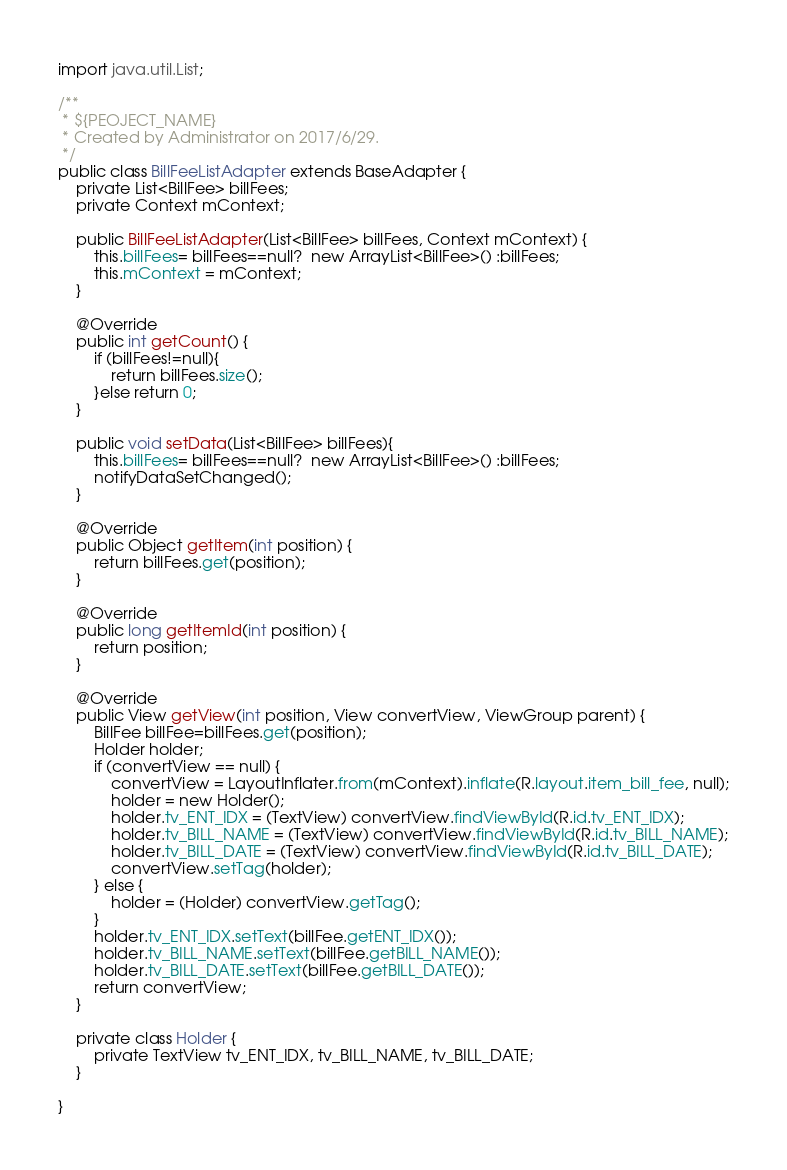<code> <loc_0><loc_0><loc_500><loc_500><_Java_>import java.util.List;

/**
 * ${PEOJECT_NAME}
 * Created by Administrator on 2017/6/29.
 */
public class BillFeeListAdapter extends BaseAdapter {
    private List<BillFee> billFees;
    private Context mContext;

    public BillFeeListAdapter(List<BillFee> billFees, Context mContext) {
        this.billFees= billFees==null?  new ArrayList<BillFee>() :billFees;
        this.mContext = mContext;
    }

    @Override
    public int getCount() {
        if (billFees!=null){
            return billFees.size();
        }else return 0;
    }

    public void setData(List<BillFee> billFees){
        this.billFees= billFees==null?  new ArrayList<BillFee>() :billFees;
        notifyDataSetChanged();
    }

    @Override
    public Object getItem(int position) {
        return billFees.get(position);
    }

    @Override
    public long getItemId(int position) {
        return position;
    }

    @Override
    public View getView(int position, View convertView, ViewGroup parent) {
        BillFee billFee=billFees.get(position);
        Holder holder;
        if (convertView == null) {
            convertView = LayoutInflater.from(mContext).inflate(R.layout.item_bill_fee, null);
            holder = new Holder();
            holder.tv_ENT_IDX = (TextView) convertView.findViewById(R.id.tv_ENT_IDX);
            holder.tv_BILL_NAME = (TextView) convertView.findViewById(R.id.tv_BILL_NAME);
            holder.tv_BILL_DATE = (TextView) convertView.findViewById(R.id.tv_BILL_DATE);
            convertView.setTag(holder);
        } else {
            holder = (Holder) convertView.getTag();
        }
        holder.tv_ENT_IDX.setText(billFee.getENT_IDX());
        holder.tv_BILL_NAME.setText(billFee.getBILL_NAME());
        holder.tv_BILL_DATE.setText(billFee.getBILL_DATE());
        return convertView;
    }

    private class Holder {
        private TextView tv_ENT_IDX, tv_BILL_NAME, tv_BILL_DATE;
    }

}
</code> 